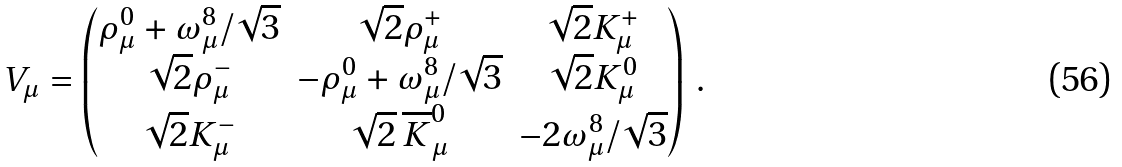<formula> <loc_0><loc_0><loc_500><loc_500>V _ { \mu } = \begin{pmatrix} \rho _ { \mu } ^ { 0 } + \omega _ { \mu } ^ { 8 } / \sqrt { 3 } & \sqrt { 2 } \rho _ { \mu } ^ { + } & \sqrt { 2 } K _ { \mu } ^ { + } \\ \sqrt { 2 } \rho _ { \mu } ^ { - } & - \rho ^ { 0 } _ { \mu } + \omega _ { \mu } ^ { 8 } / \sqrt { 3 } & \sqrt { 2 } K _ { \mu } ^ { 0 } \\ \sqrt { 2 } K _ { \mu } ^ { - } & \sqrt { 2 } \, \overline { K } _ { \mu } ^ { 0 } & - 2 \omega _ { \mu } ^ { 8 } / \sqrt { 3 } \end{pmatrix} \, .</formula> 